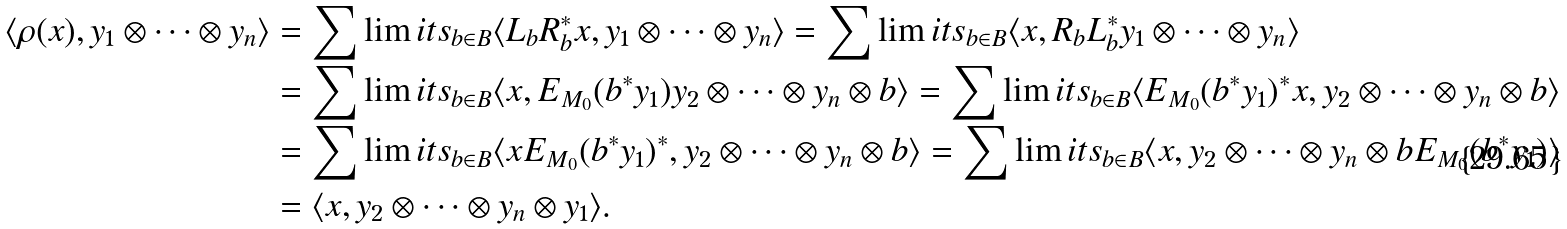<formula> <loc_0><loc_0><loc_500><loc_500>\langle \rho ( x ) , y _ { 1 } \otimes \cdots \otimes y _ { n } \rangle & = \sum \lim i t s _ { b \in B } \langle L _ { b } R _ { b } ^ { * } x , y _ { 1 } \otimes \cdots \otimes y _ { n } \rangle = \sum \lim i t s _ { b \in B } \langle x , R _ { b } L _ { b } ^ { * } y _ { 1 } \otimes \cdots \otimes y _ { n } \rangle \\ & = \sum \lim i t s _ { b \in B } \langle x , E _ { M _ { 0 } } ( b ^ { * } y _ { 1 } ) y _ { 2 } \otimes \cdots \otimes y _ { n } \otimes b \rangle = \sum \lim i t s _ { b \in B } \langle E _ { M _ { 0 } } ( b ^ { * } y _ { 1 } ) ^ { * } x , y _ { 2 } \otimes \cdots \otimes y _ { n } \otimes b \rangle \\ & = \sum \lim i t s _ { b \in B } \langle x E _ { M _ { 0 } } ( b ^ { * } y _ { 1 } ) ^ { * } , y _ { 2 } \otimes \cdots \otimes y _ { n } \otimes b \rangle = \sum \lim i t s _ { b \in B } \langle x , y _ { 2 } \otimes \cdots \otimes y _ { n } \otimes b E _ { M _ { 0 } } ( b ^ { * } y _ { 1 } ) \rangle \\ & = \langle x , y _ { 2 } \otimes \cdots \otimes y _ { n } \otimes y _ { 1 } \rangle .</formula> 